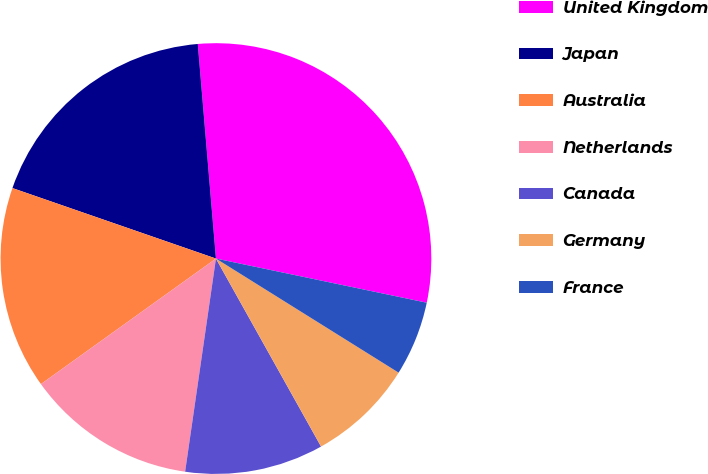Convert chart. <chart><loc_0><loc_0><loc_500><loc_500><pie_chart><fcel>United Kingdom<fcel>Japan<fcel>Australia<fcel>Netherlands<fcel>Canada<fcel>Germany<fcel>France<nl><fcel>29.63%<fcel>18.35%<fcel>15.21%<fcel>12.81%<fcel>10.4%<fcel>8.0%<fcel>5.6%<nl></chart> 